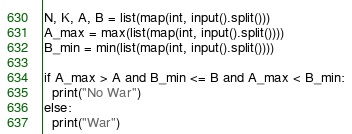Convert code to text. <code><loc_0><loc_0><loc_500><loc_500><_Python_>N, K, A, B = list(map(int, input().split()))
A_max = max(list(map(int, input().split())))
B_min = min(list(map(int, input().split())))

if A_max > A and B_min <= B and A_max < B_min:
  print("No War")
else:
  print("War")</code> 